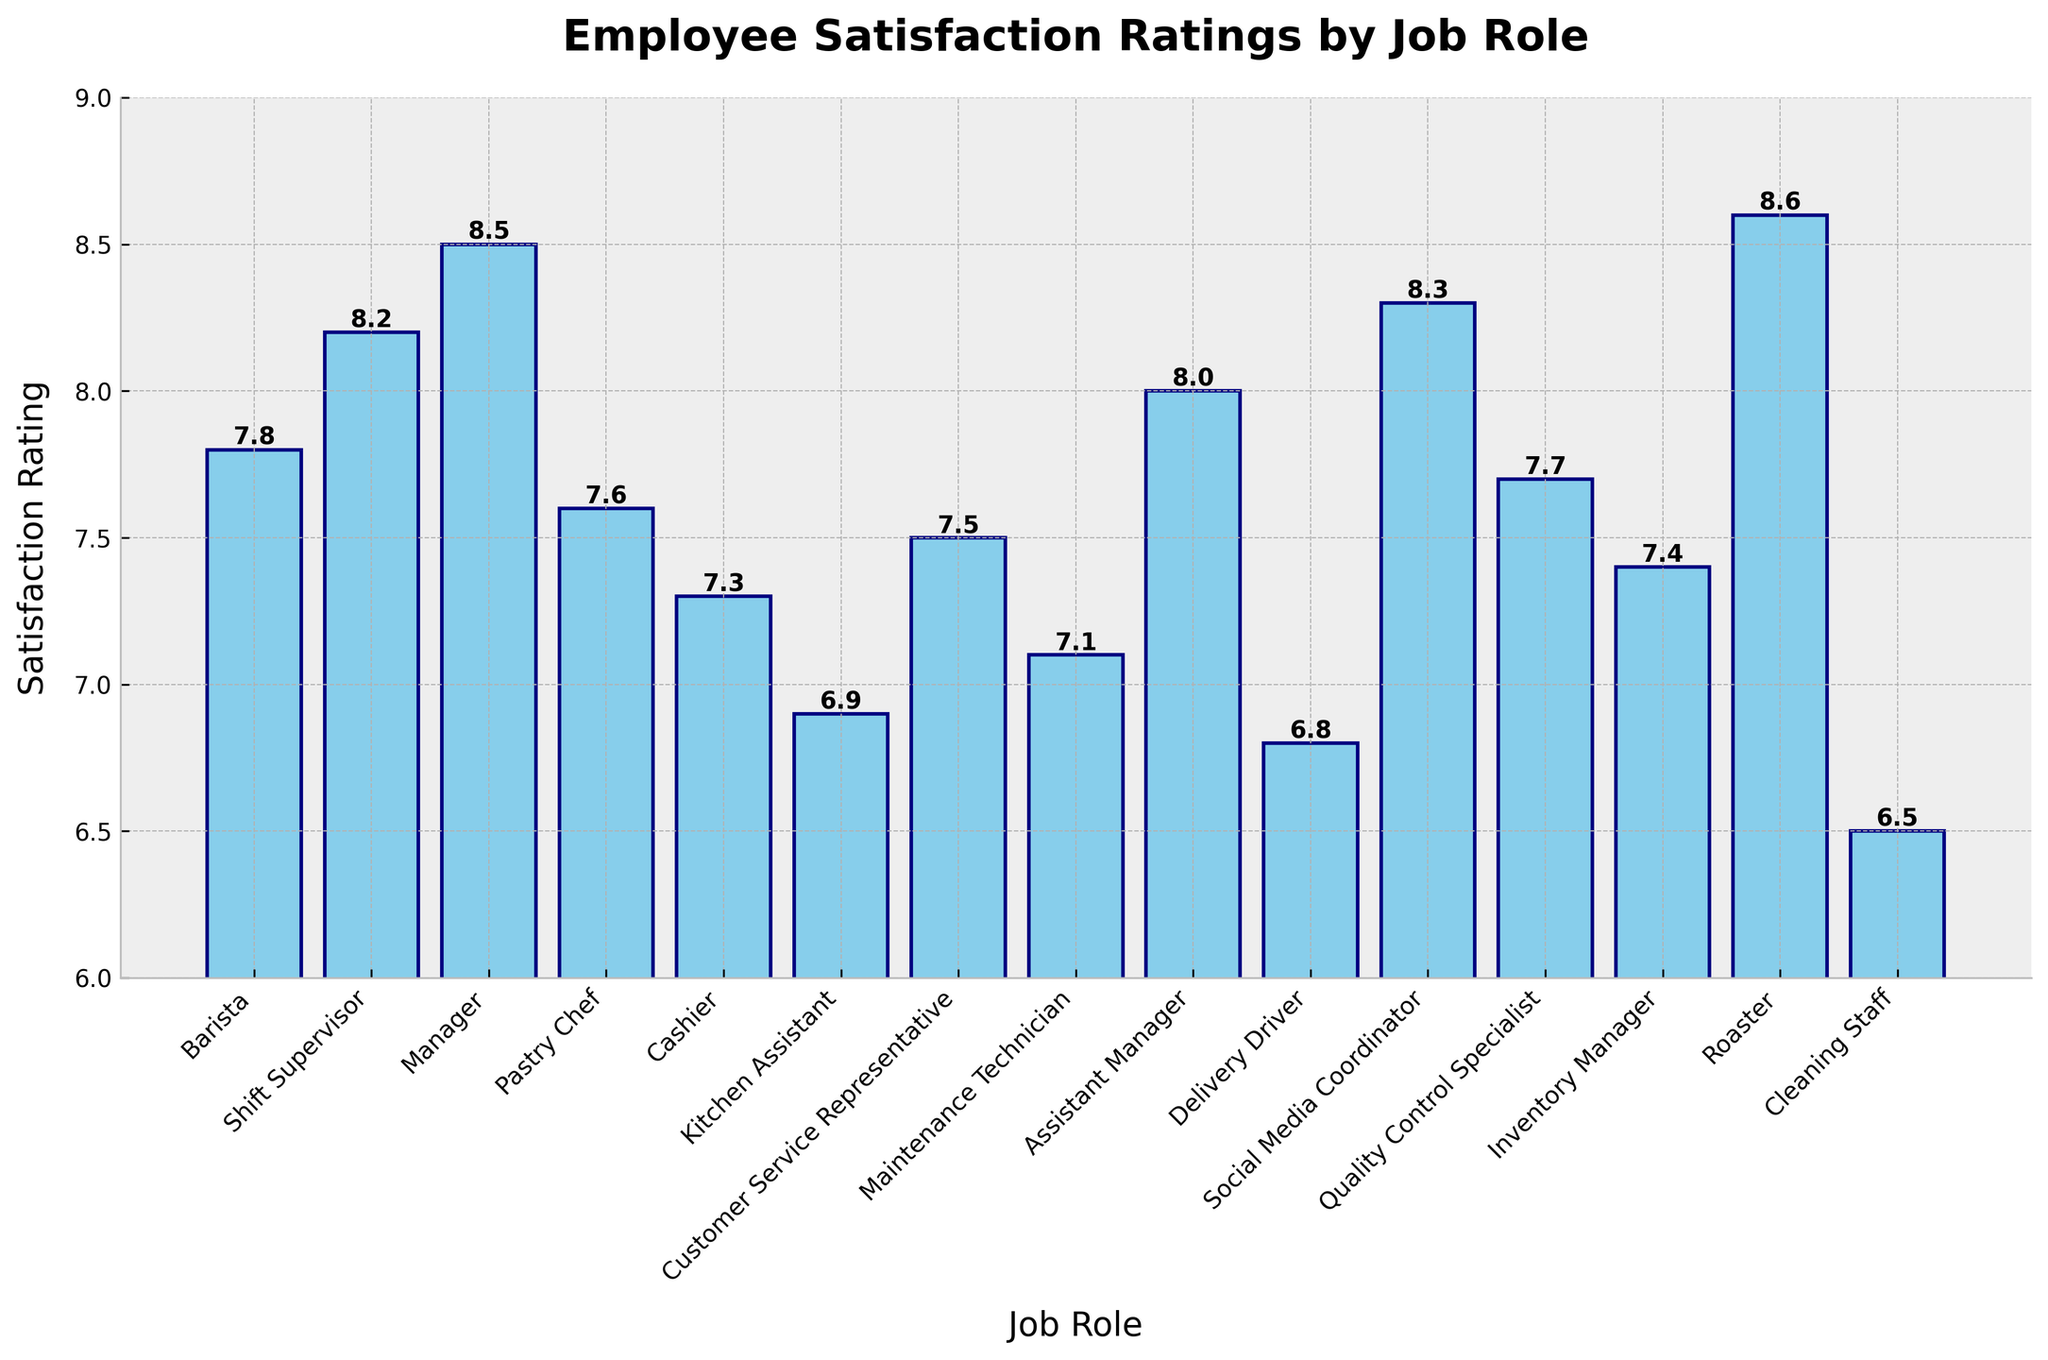What's the highest employee satisfaction rating by job role? First, identify the job role with the highest bar in the chart. Then, look at the satisfaction rating label on top of this bar. The tallest bar corresponds to the 'Roaster' with a satisfaction rating of 8.6.
Answer: Roaster What is the difference between the highest and lowest employee satisfaction ratings? Identify the highest rating (Roaster, 8.6) and the lowest rating (Cleaning Staff, 6.5). Subtract the lowest from the highest: 8.6 - 6.5 = 2.1.
Answer: 2.1 What is the average satisfaction rating of the Barista, Cashier, and Kitchen Assistant roles? Sum the ratings of the Barista (7.8), Cashier (7.3), and Kitchen Assistant (6.9): 7.8 + 7.3 + 6.9 = 22. Then, divide by the number of roles (3): 22 / 3 = 7.33.
Answer: 7.33 Which job role has a satisfaction rating closest to the overall average rating of all roles? Calculate the overall average rating by summing all ratings and dividing by the number of roles: (7.8 + 8.2 + 8.5 + 7.6 + 7.3 + 6.9 + 7.5 + 7.1 + 8.0 + 6.8 + 8.3 + 7.7 + 7.4 + 8.6 + 6.5)/15 = 7.6. Then, find the role with the rating closest to 7.6, which is 'Pastry Chef' with a rating of 7.6.
Answer: Pastry Chef Which job roles have a satisfaction rating greater than 8.0? Identify all bars with satisfaction ratings greater than 8.0. These include 'Shift Supervisor' (8.2), 'Manager' (8.5), 'Social Media Coordinator' (8.3), 'Assistant Manager' (8.0), and 'Roaster' (8.6).
Answer: Shift Supervisor, Manager, Social Media Coordinator, Assistant Manager, Roaster What is the total satisfaction rating for all customer-facing roles (Barista, Cashier, Customer Service Representative)? Sum the ratings of Barista (7.8), Cashier (7.3), and Customer Service Representative (7.5): 7.8 + 7.3 + 7.5 = 22.6.
Answer: 22.6 Which job role has the second-lowest satisfaction rating? Identify the second shortest bar in the chart. The shortest is 'Cleaning Staff' with 6.5, and the second shortest is 'Delivery Driver' with 6.8.
Answer: Delivery Driver How many job roles have a satisfaction rating between 7.0 and 8.0? Count the bars with satisfaction ratings between 7.0 and 8.0. These are 'Barista' (7.8), 'Pastry Chef' (7.6), 'Cashier' (7.3), 'Customer Service Representative' (7.5), 'Maintenance Technician' (7.1), 'Quality Control Specialist' (7.7), and 'Inventory Manager' (7.4), which total 7 roles.
Answer: 7 